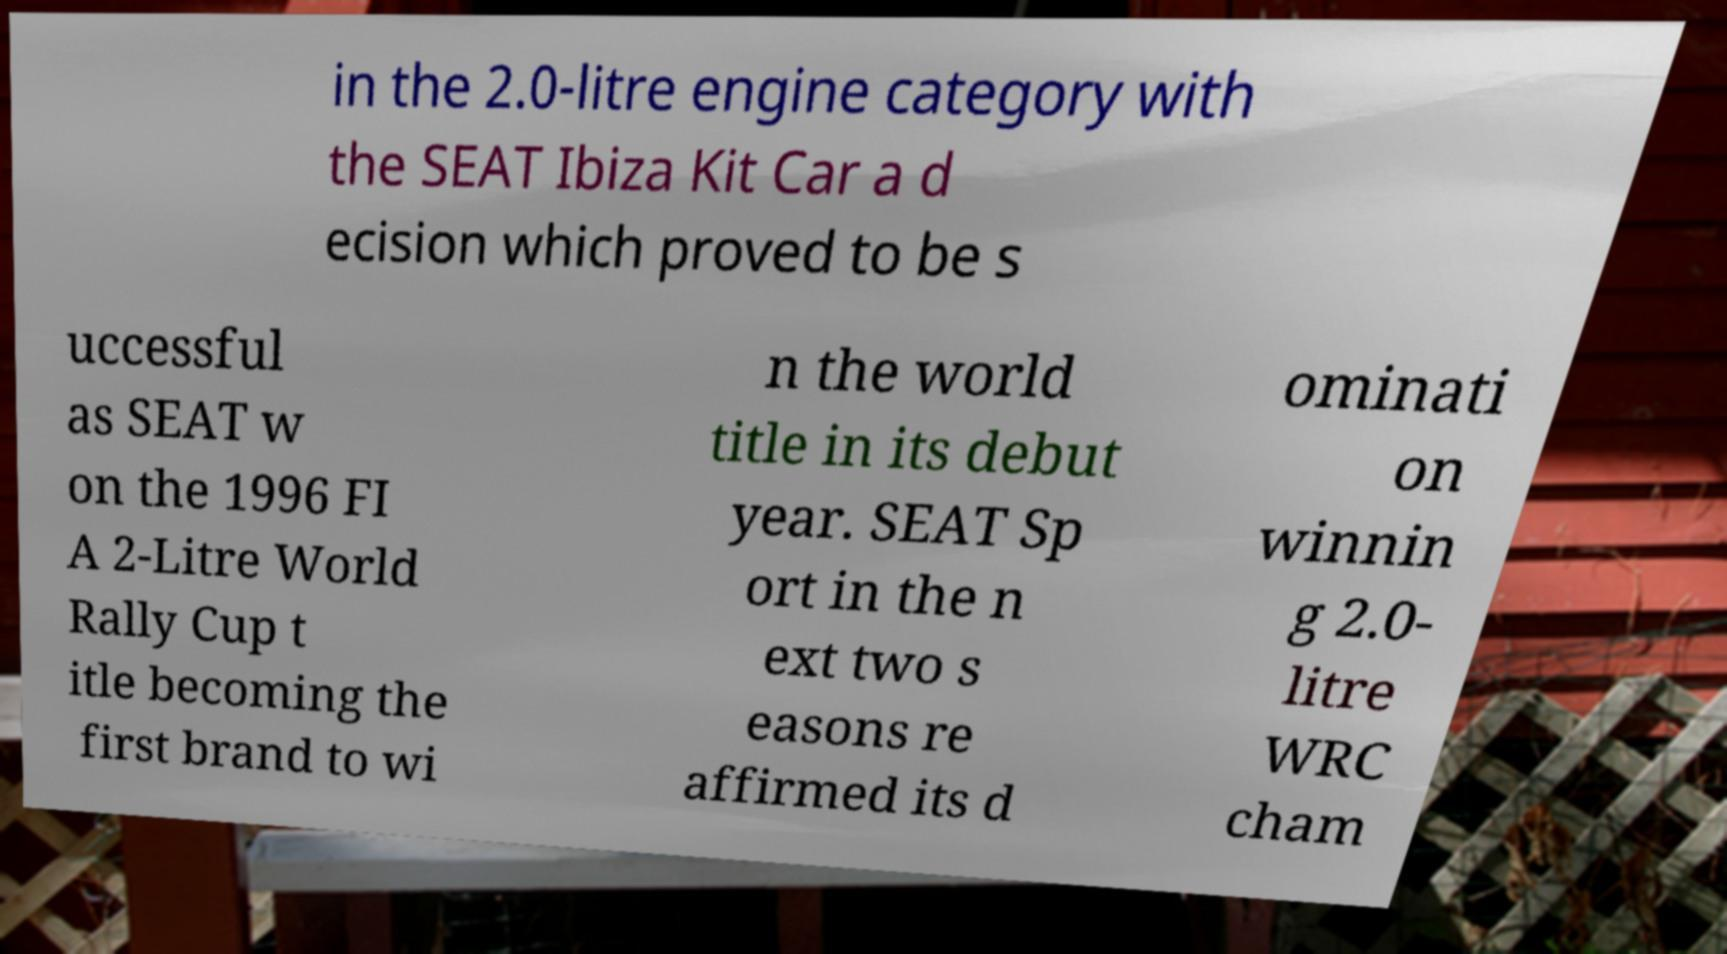Please read and relay the text visible in this image. What does it say? in the 2.0-litre engine category with the SEAT Ibiza Kit Car a d ecision which proved to be s uccessful as SEAT w on the 1996 FI A 2-Litre World Rally Cup t itle becoming the first brand to wi n the world title in its debut year. SEAT Sp ort in the n ext two s easons re affirmed its d ominati on winnin g 2.0- litre WRC cham 